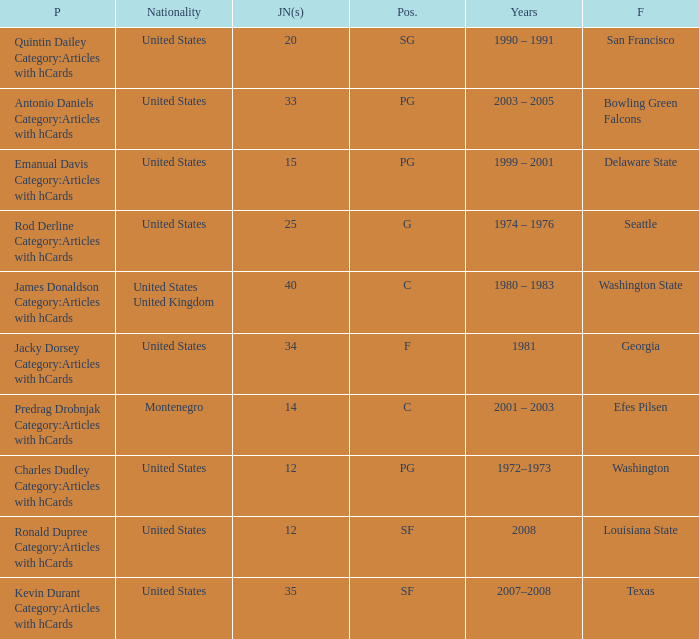What was the nationality of the players with a position of g? United States. 